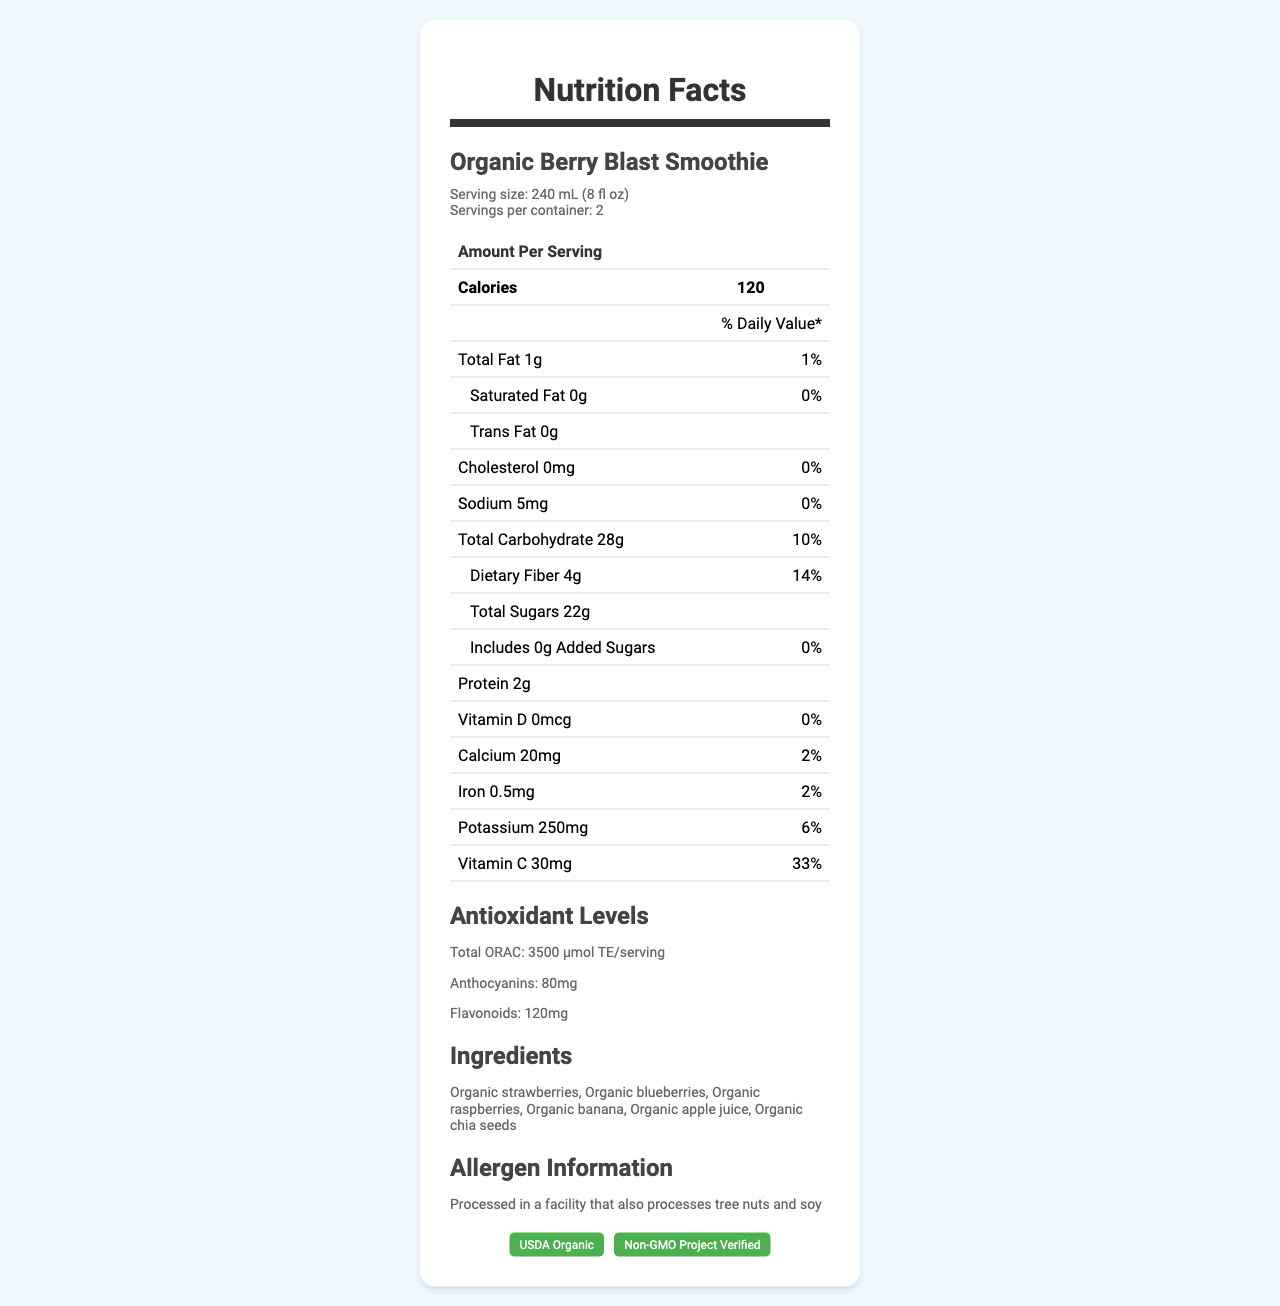What is the serving size for the Organic Berry Blast Smoothie? The serving size is specified directly under the product name and is 240 mL (8 fl oz).
Answer: 240 mL (8 fl oz) What is the total carbohydrate content per serving? The total carbohydrate content is listed in the table under the "Amount Per Serving" section and is 28g.
Answer: 28g How many calories are there per serving of the Organic Berry Blast Smoothie? The calories per serving are specified as 120 in the "Amount Per Serving" section of the table.
Answer: 120 Does this product contain any added sugars? The document states that added sugars amount to 0g and 0% of the Daily Value.
Answer: No What vitamins are included in the Nutrition Facts? The vitamins listed are Vitamin D, calcium, iron, potassium, and vitamin C as shown in the table.
Answer: Vitamin D, calcium, iron, potassium, and vitamin C What is the antioxidant level measured in ORAC for one serving? The antioxidant level in terms of ORAC for one serving is specified as 3500 µmol TE/serving in the "Antioxidant Levels" section.
Answer: 3500 µmol TE/serving Which ingredients are used in the Organic Berry Blast Smoothie? a) Organic bananas and apples only b) Various organic berries and chia seeds c) Organic vegetables and flax seeds The ingredients listed include organic strawberries, blueberries, raspberries, banana, apple juice, and chia seeds.
Answer: b) Various organic berries and chia seeds What is the percentage of the Daily Value for calcium provided per serving? a) 1% b) 2% c) 5% d) 10% According to the table, the calcium provided per serving is 20mg, which is 2% of the Daily Value.
Answer: b) 2% Is this product USDA Organic certified? The document mentions that the product is USDA Organic certified, visible in the certifications section.
Answer: Yes Summarize the main nutritional highlights of the Organic Berry Blast Smoothie. This document provides detailed nutritional information for the Organic Berry Blast Smoothie, including calorie content, macronutrient breakdown, significant vitamins and minerals, antioxidant levels, ingredients, and certifications.
Answer: The Organic Berry Blast Smoothie is an organic, nutrient-rich beverage containing 120 calories per serving with high levels of natural sugars, dietary fiber, and antioxidants. It includes various organic berries and chia seeds and is certified USDA Organic and Non-GMO Project Verified. Benefits include significant amounts of vitamin C and potassium, and no added sugars. What is the total antioxidant content of flavonoids in mg? The antioxidant levels section specifies that the flavonoids content is 120mg per serving.
Answer: 120mg Are there any allergens listed for this product? The allergen information section indicates that the product is processed in a facility that also processes tree nuts and soy.
Answer: Yes Does the Organic Berry Blast Smoothie contain any cholesterol? The cholesterol content per serving is 0mg and 0% of the Daily Value.
Answer: No What is the serving size in fluid ounces? The serving size is also provided in fluid ounces as 8 fl oz.
Answer: 8 fl oz Which company manufactures this smoothie? The document does not provide information about the manufacturer of the smoothie.
Answer: Cannot be determined 